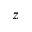Convert formula to latex. <formula><loc_0><loc_0><loc_500><loc_500>z</formula> 